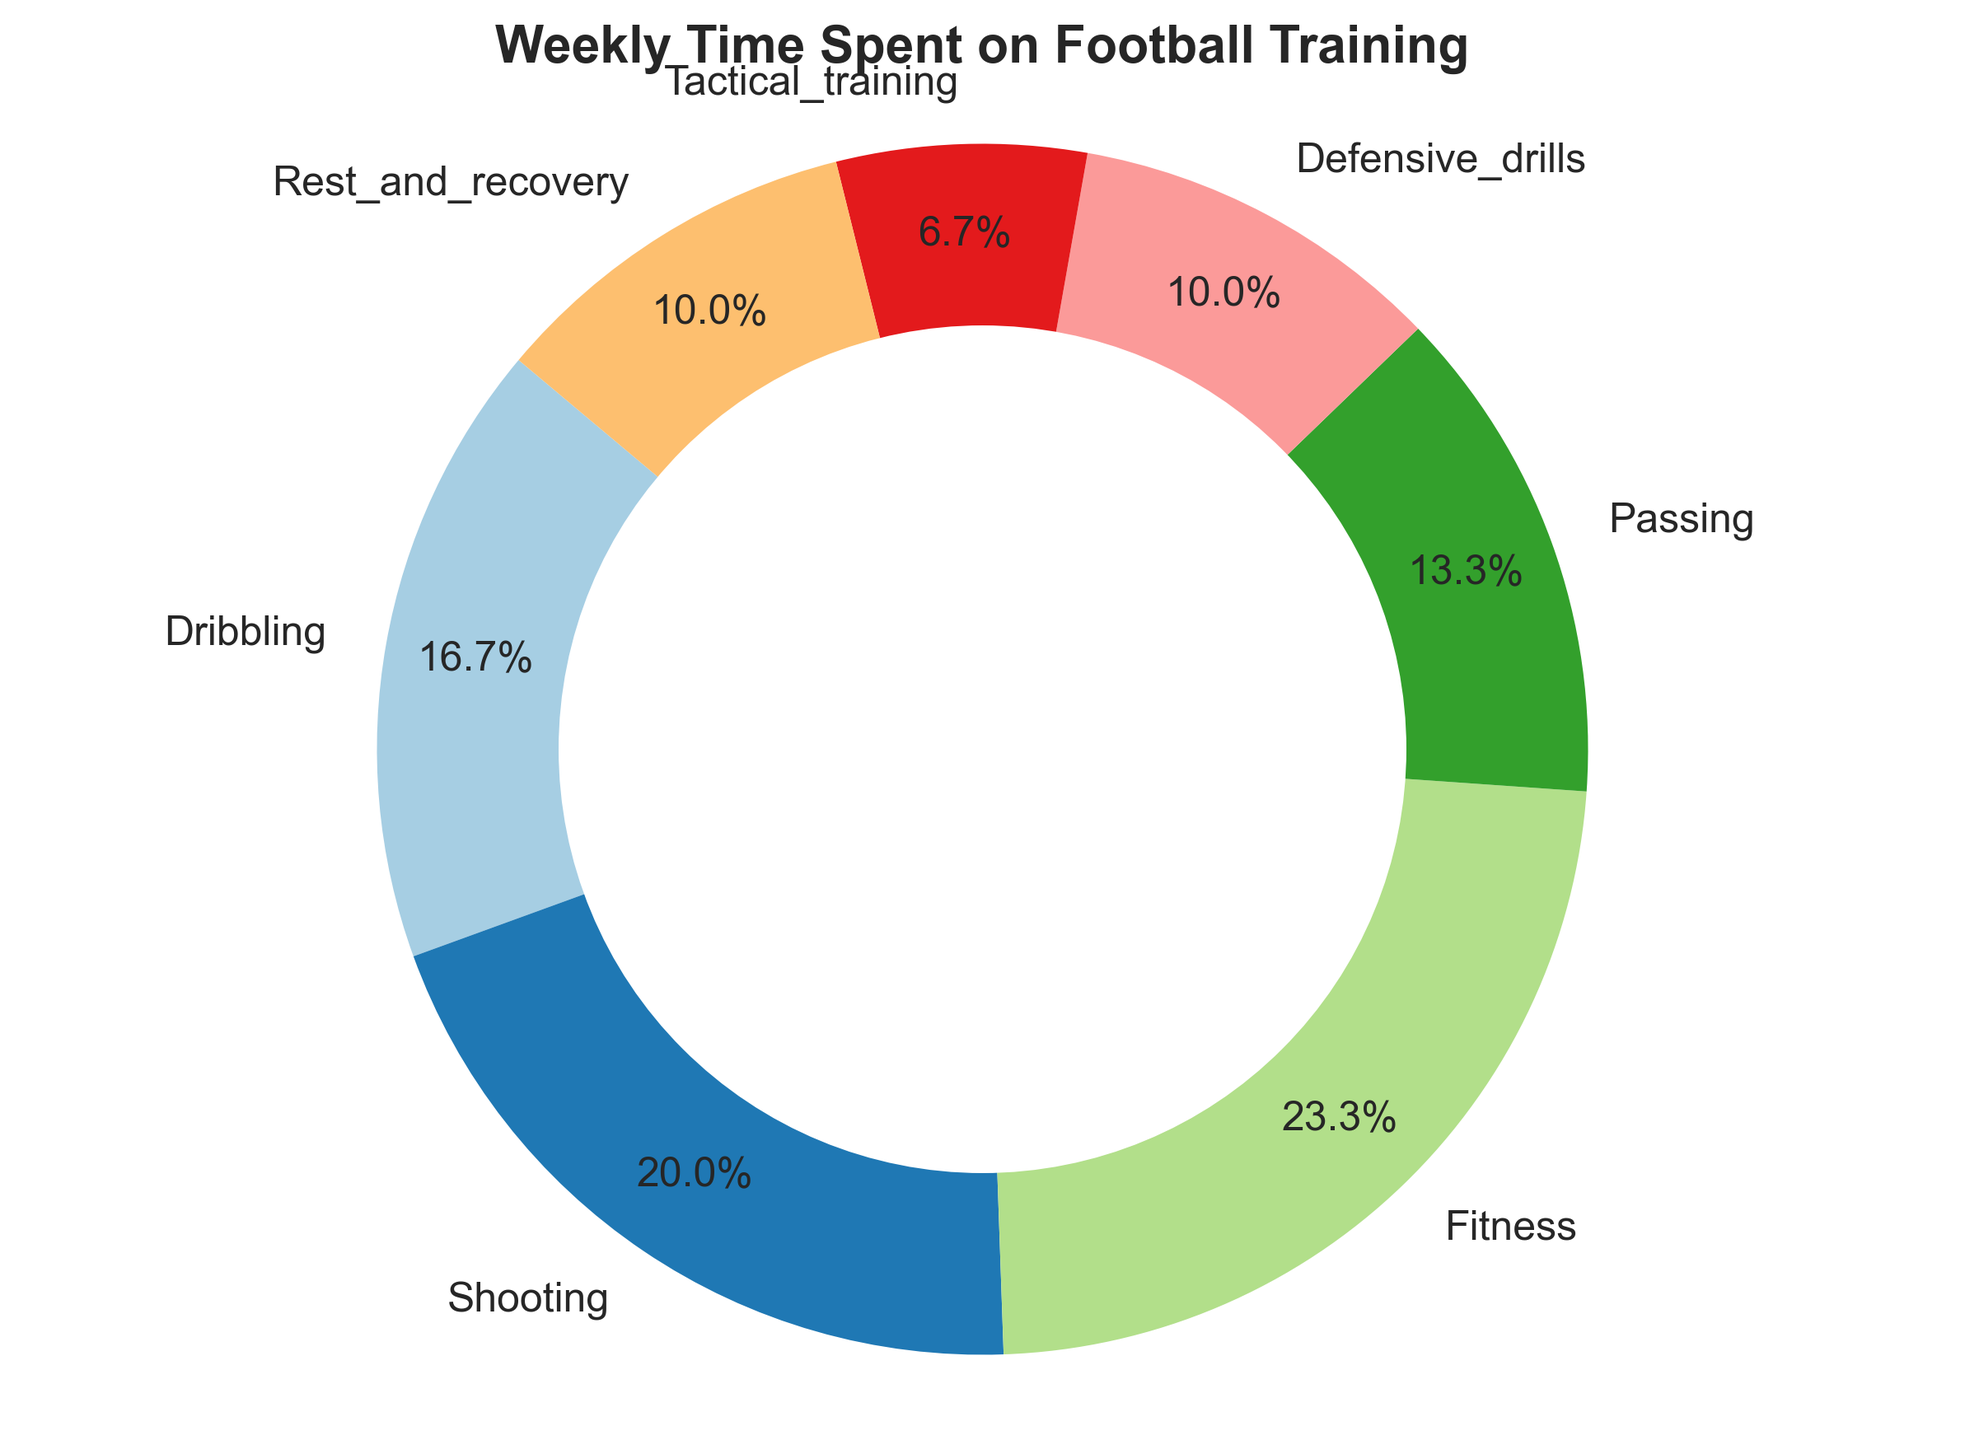What percentage of time is spent on Dribbling? Dribbling takes up a segment in the pie chart labeled with its percentage. We can see that the segment for Dribbling shows 20.8%.
Answer: 20.8% Which activity takes the most time per week? The pie chart segment with the largest area represents the activity with the most time. By comparing the segments, Fitness has the largest area.
Answer: Fitness What is the total time spent on Fitness and Shooting combined? According to the data, Fitness takes 7 hours per week, and Shooting takes 6 hours per week. By adding these, we get 7 + 6 = 13 hours.
Answer: 13 hours Which two training activities take an equal amount of time per week and what is that time? By checking the data and the pie chart, Rest and Recovery and Defensive Drills each take 3 hours per week.
Answer: Rest and Recovery and Defensive Drills; 3 hours How much more time is spent on Shooting compared to Defensive Drills? The data shows Shooting takes 6 hours per week, and Defensive Drills take 3 hours per week. The difference is 6 - 3 = 3 hours.
Answer: 3 hours Which portion of the pie chart represents the least amount of time spent on a training activity? By comparing the segments, Tactical Training has the smallest area.
Answer: Tactical Training What is the average weekly time spent on Dribbling, Passing, and Tactical Training combined? Dribbling takes 5 hours, Passing takes 4 hours, and Tactical Training takes 2 hours. The total is 5 + 4 + 2 = 11 hours. The average is 11 / 3 = 3.67 hours.
Answer: 3.67 hours How do the time spent on Shooting and Dribbling compare? From the pie chart, Shooting and Dribbling segments show 25.0% and 20.8%, respectively. Shooting takes more time than Dribbling.
Answer: Shooting takes more time What is the cumulative percentage of time spent on Passing, Defensive Drills, and Tactical Training? From the pie chart, Passing is 16.7%, Defensive Drills is 12.5%, and Tactical Training is 8.3%. The cumulative percentage is 16.7 + 12.5 + 8.3 = 37.5%.
Answer: 37.5% If you combine Rest and Recovery with Passing, what percentage of the training time does this represent? Rest and Recovery is 12.5%, and Passing is 16.7%. Combined, they make up 12.5 + 16.7 = 29.2% of the total training time.
Answer: 29.2% 